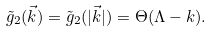Convert formula to latex. <formula><loc_0><loc_0><loc_500><loc_500>\tilde { g } _ { 2 } ( \vec { k } ) = \tilde { g } _ { 2 } ( | \vec { k } | ) = \Theta ( \Lambda - k ) .</formula> 